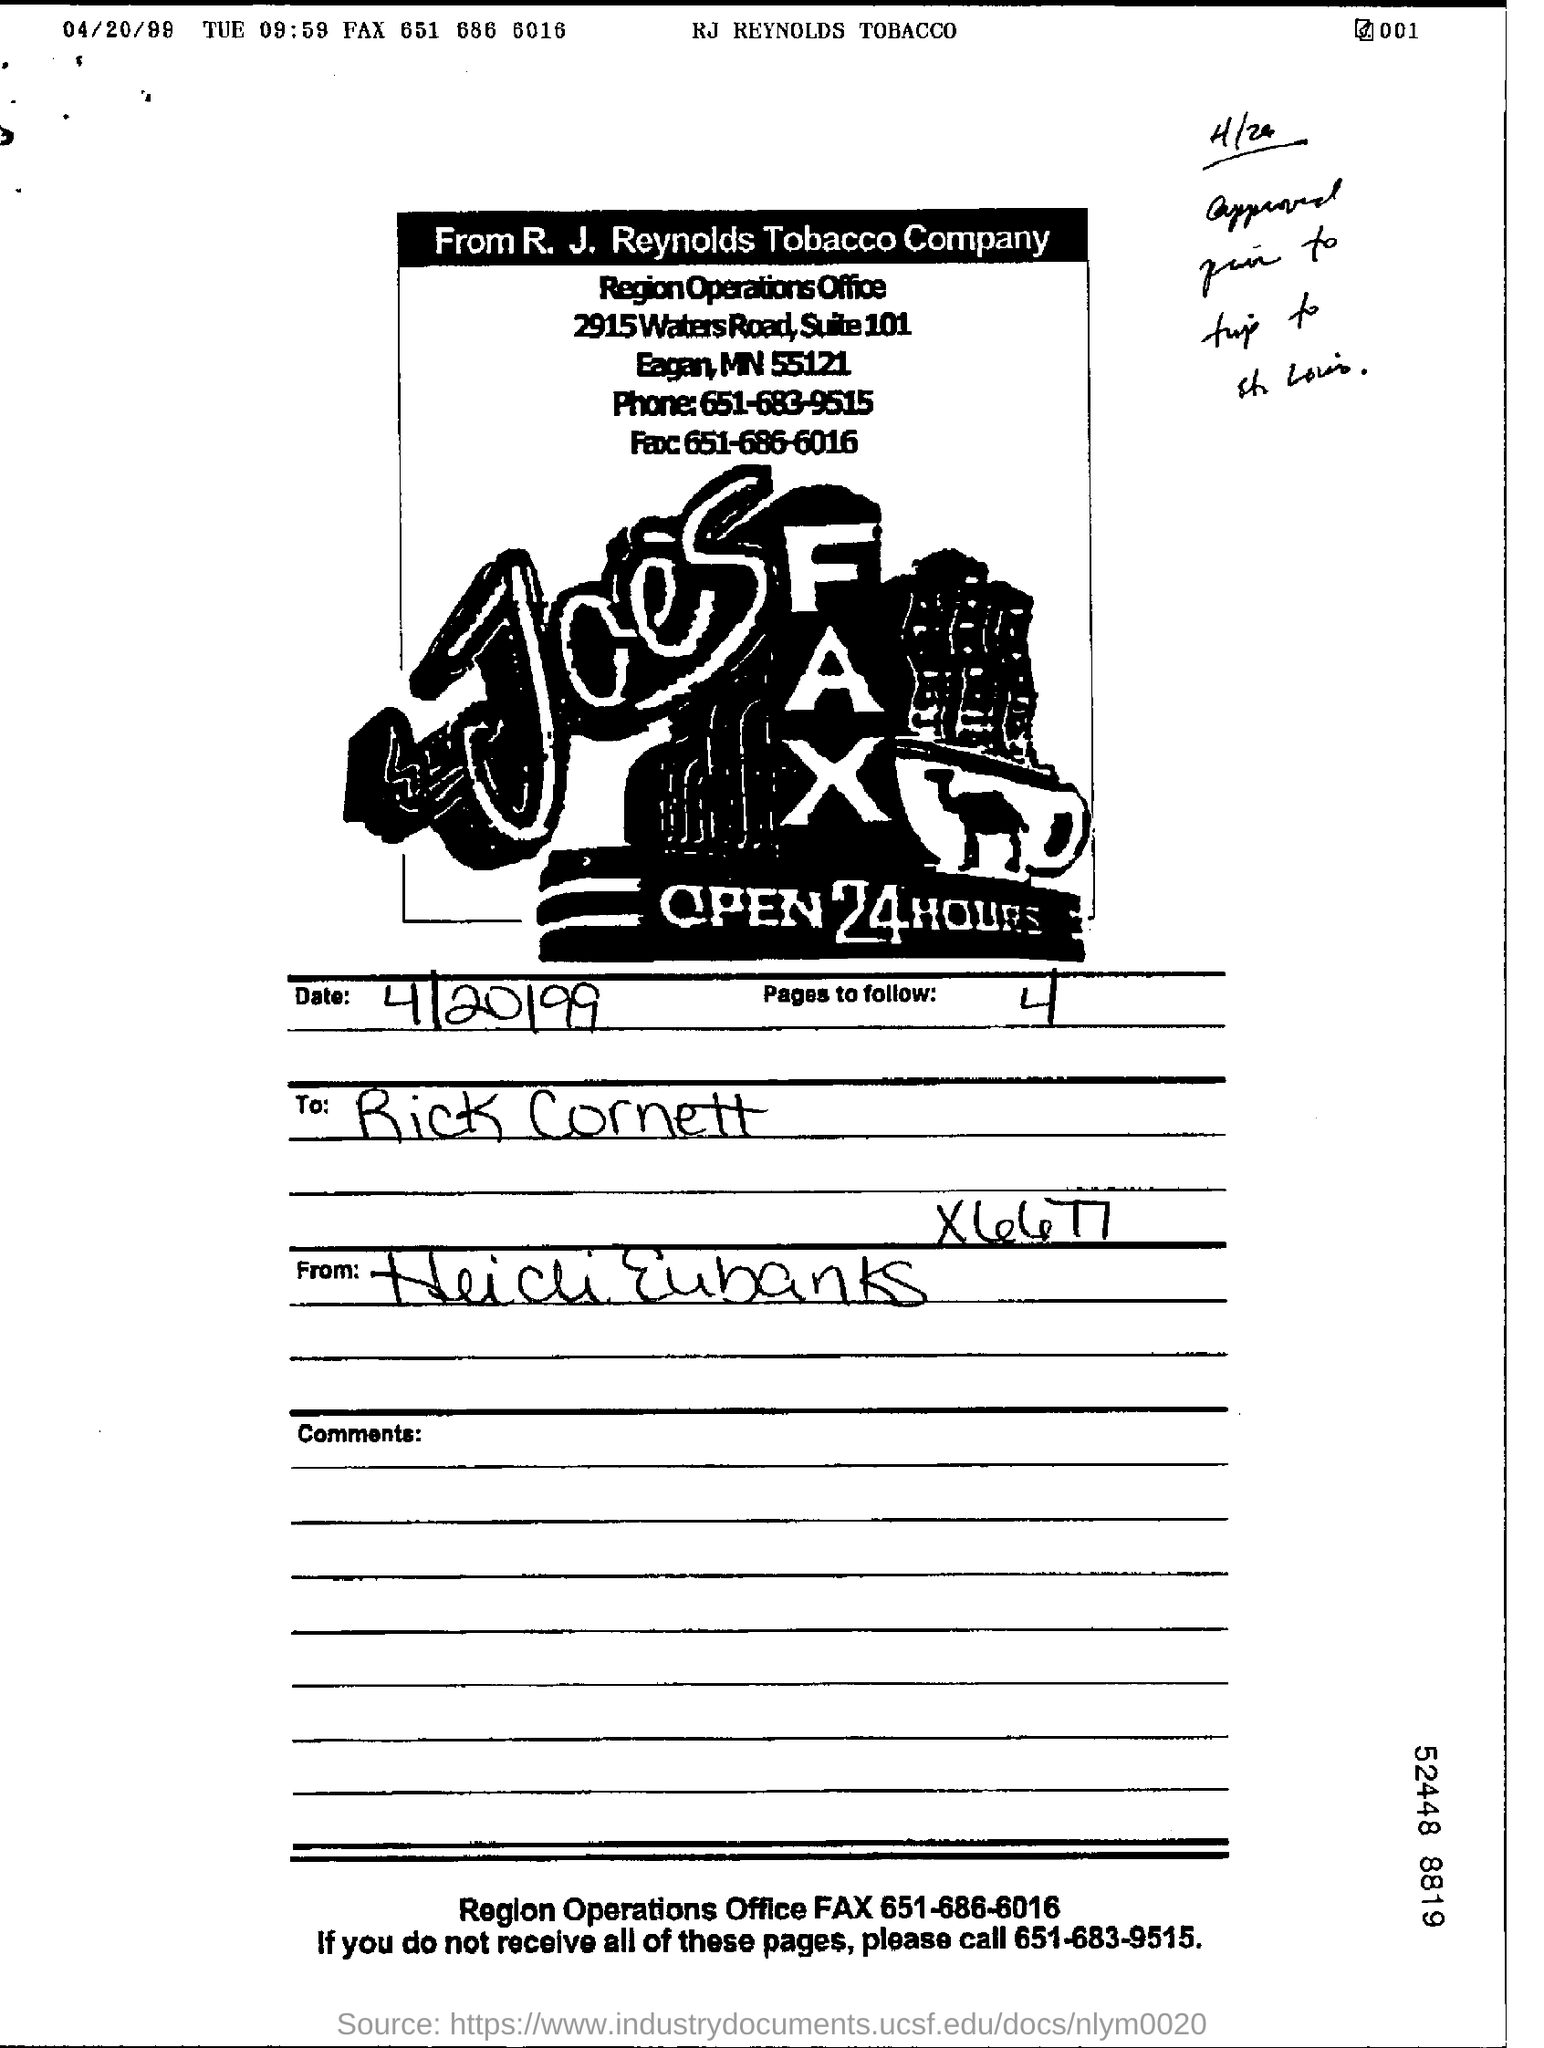How many pages to follow?
Offer a very short reply. 4. 